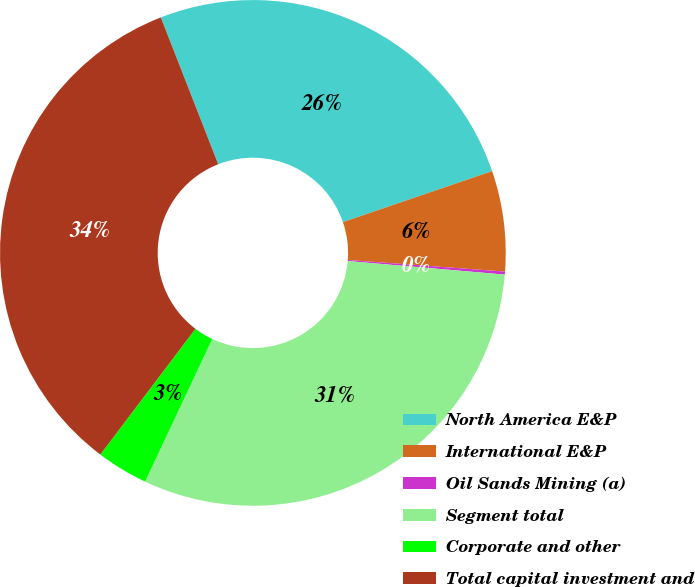Convert chart to OTSL. <chart><loc_0><loc_0><loc_500><loc_500><pie_chart><fcel>North America E&P<fcel>International E&P<fcel>Oil Sands Mining (a)<fcel>Segment total<fcel>Corporate and other<fcel>Total capital investment and<nl><fcel>25.69%<fcel>6.42%<fcel>0.19%<fcel>30.64%<fcel>3.3%<fcel>33.76%<nl></chart> 